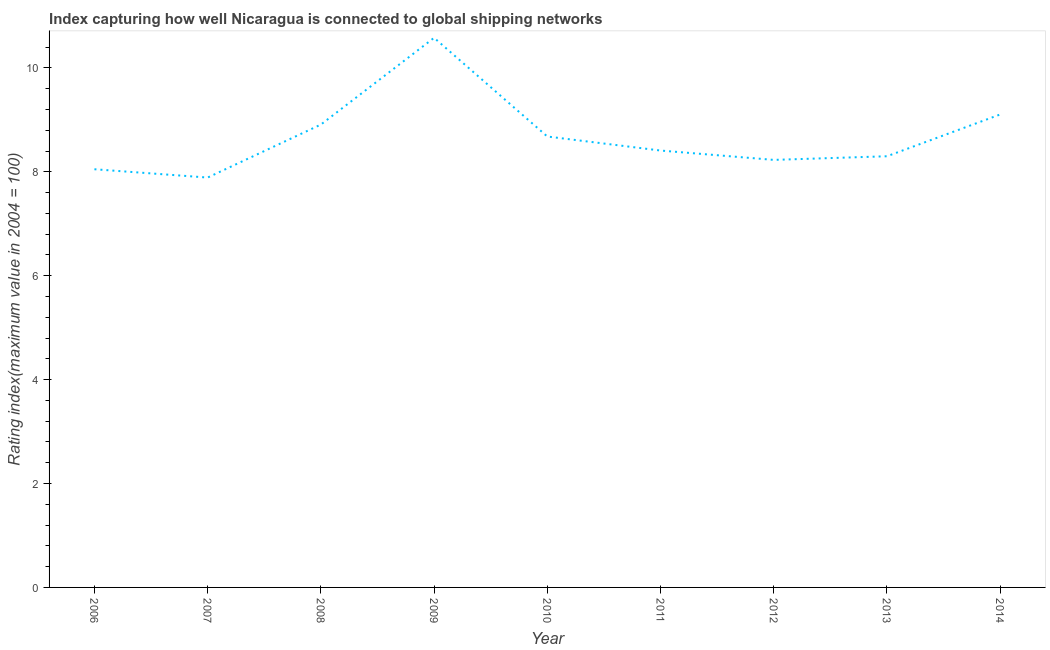What is the liner shipping connectivity index in 2009?
Give a very brief answer. 10.58. Across all years, what is the maximum liner shipping connectivity index?
Offer a very short reply. 10.58. Across all years, what is the minimum liner shipping connectivity index?
Keep it short and to the point. 7.89. What is the sum of the liner shipping connectivity index?
Ensure brevity in your answer.  78.15. What is the difference between the liner shipping connectivity index in 2012 and 2013?
Your answer should be very brief. -0.07. What is the average liner shipping connectivity index per year?
Your response must be concise. 8.68. What is the median liner shipping connectivity index?
Ensure brevity in your answer.  8.41. Do a majority of the years between 2010 and 2006 (inclusive) have liner shipping connectivity index greater than 5.6 ?
Give a very brief answer. Yes. What is the ratio of the liner shipping connectivity index in 2006 to that in 2014?
Offer a terse response. 0.88. Is the difference between the liner shipping connectivity index in 2008 and 2012 greater than the difference between any two years?
Make the answer very short. No. What is the difference between the highest and the second highest liner shipping connectivity index?
Offer a very short reply. 1.48. What is the difference between the highest and the lowest liner shipping connectivity index?
Give a very brief answer. 2.69. Does the liner shipping connectivity index monotonically increase over the years?
Your answer should be very brief. No. How many lines are there?
Your answer should be compact. 1. How many years are there in the graph?
Your response must be concise. 9. Are the values on the major ticks of Y-axis written in scientific E-notation?
Make the answer very short. No. Does the graph contain grids?
Make the answer very short. No. What is the title of the graph?
Your response must be concise. Index capturing how well Nicaragua is connected to global shipping networks. What is the label or title of the X-axis?
Keep it short and to the point. Year. What is the label or title of the Y-axis?
Provide a short and direct response. Rating index(maximum value in 2004 = 100). What is the Rating index(maximum value in 2004 = 100) of 2006?
Provide a short and direct response. 8.05. What is the Rating index(maximum value in 2004 = 100) of 2007?
Give a very brief answer. 7.89. What is the Rating index(maximum value in 2004 = 100) of 2008?
Give a very brief answer. 8.91. What is the Rating index(maximum value in 2004 = 100) in 2009?
Your response must be concise. 10.58. What is the Rating index(maximum value in 2004 = 100) of 2010?
Offer a very short reply. 8.68. What is the Rating index(maximum value in 2004 = 100) of 2011?
Offer a very short reply. 8.41. What is the Rating index(maximum value in 2004 = 100) in 2012?
Provide a succinct answer. 8.23. What is the Rating index(maximum value in 2004 = 100) of 2014?
Your answer should be compact. 9.1. What is the difference between the Rating index(maximum value in 2004 = 100) in 2006 and 2007?
Your answer should be compact. 0.16. What is the difference between the Rating index(maximum value in 2004 = 100) in 2006 and 2008?
Your answer should be compact. -0.86. What is the difference between the Rating index(maximum value in 2004 = 100) in 2006 and 2009?
Provide a succinct answer. -2.53. What is the difference between the Rating index(maximum value in 2004 = 100) in 2006 and 2010?
Make the answer very short. -0.63. What is the difference between the Rating index(maximum value in 2004 = 100) in 2006 and 2011?
Make the answer very short. -0.36. What is the difference between the Rating index(maximum value in 2004 = 100) in 2006 and 2012?
Make the answer very short. -0.18. What is the difference between the Rating index(maximum value in 2004 = 100) in 2006 and 2013?
Your response must be concise. -0.25. What is the difference between the Rating index(maximum value in 2004 = 100) in 2006 and 2014?
Your response must be concise. -1.05. What is the difference between the Rating index(maximum value in 2004 = 100) in 2007 and 2008?
Give a very brief answer. -1.02. What is the difference between the Rating index(maximum value in 2004 = 100) in 2007 and 2009?
Ensure brevity in your answer.  -2.69. What is the difference between the Rating index(maximum value in 2004 = 100) in 2007 and 2010?
Keep it short and to the point. -0.79. What is the difference between the Rating index(maximum value in 2004 = 100) in 2007 and 2011?
Offer a terse response. -0.52. What is the difference between the Rating index(maximum value in 2004 = 100) in 2007 and 2012?
Offer a terse response. -0.34. What is the difference between the Rating index(maximum value in 2004 = 100) in 2007 and 2013?
Ensure brevity in your answer.  -0.41. What is the difference between the Rating index(maximum value in 2004 = 100) in 2007 and 2014?
Ensure brevity in your answer.  -1.21. What is the difference between the Rating index(maximum value in 2004 = 100) in 2008 and 2009?
Offer a very short reply. -1.67. What is the difference between the Rating index(maximum value in 2004 = 100) in 2008 and 2010?
Provide a succinct answer. 0.23. What is the difference between the Rating index(maximum value in 2004 = 100) in 2008 and 2011?
Provide a succinct answer. 0.5. What is the difference between the Rating index(maximum value in 2004 = 100) in 2008 and 2012?
Provide a short and direct response. 0.68. What is the difference between the Rating index(maximum value in 2004 = 100) in 2008 and 2013?
Ensure brevity in your answer.  0.61. What is the difference between the Rating index(maximum value in 2004 = 100) in 2008 and 2014?
Your answer should be compact. -0.19. What is the difference between the Rating index(maximum value in 2004 = 100) in 2009 and 2011?
Make the answer very short. 2.17. What is the difference between the Rating index(maximum value in 2004 = 100) in 2009 and 2012?
Offer a very short reply. 2.35. What is the difference between the Rating index(maximum value in 2004 = 100) in 2009 and 2013?
Offer a very short reply. 2.28. What is the difference between the Rating index(maximum value in 2004 = 100) in 2009 and 2014?
Offer a very short reply. 1.48. What is the difference between the Rating index(maximum value in 2004 = 100) in 2010 and 2011?
Your response must be concise. 0.27. What is the difference between the Rating index(maximum value in 2004 = 100) in 2010 and 2012?
Ensure brevity in your answer.  0.45. What is the difference between the Rating index(maximum value in 2004 = 100) in 2010 and 2013?
Ensure brevity in your answer.  0.38. What is the difference between the Rating index(maximum value in 2004 = 100) in 2010 and 2014?
Ensure brevity in your answer.  -0.42. What is the difference between the Rating index(maximum value in 2004 = 100) in 2011 and 2012?
Offer a terse response. 0.18. What is the difference between the Rating index(maximum value in 2004 = 100) in 2011 and 2013?
Keep it short and to the point. 0.11. What is the difference between the Rating index(maximum value in 2004 = 100) in 2011 and 2014?
Offer a very short reply. -0.69. What is the difference between the Rating index(maximum value in 2004 = 100) in 2012 and 2013?
Provide a succinct answer. -0.07. What is the difference between the Rating index(maximum value in 2004 = 100) in 2012 and 2014?
Your response must be concise. -0.87. What is the difference between the Rating index(maximum value in 2004 = 100) in 2013 and 2014?
Provide a succinct answer. -0.8. What is the ratio of the Rating index(maximum value in 2004 = 100) in 2006 to that in 2008?
Make the answer very short. 0.9. What is the ratio of the Rating index(maximum value in 2004 = 100) in 2006 to that in 2009?
Give a very brief answer. 0.76. What is the ratio of the Rating index(maximum value in 2004 = 100) in 2006 to that in 2010?
Make the answer very short. 0.93. What is the ratio of the Rating index(maximum value in 2004 = 100) in 2006 to that in 2011?
Make the answer very short. 0.96. What is the ratio of the Rating index(maximum value in 2004 = 100) in 2006 to that in 2012?
Make the answer very short. 0.98. What is the ratio of the Rating index(maximum value in 2004 = 100) in 2006 to that in 2014?
Keep it short and to the point. 0.88. What is the ratio of the Rating index(maximum value in 2004 = 100) in 2007 to that in 2008?
Ensure brevity in your answer.  0.89. What is the ratio of the Rating index(maximum value in 2004 = 100) in 2007 to that in 2009?
Give a very brief answer. 0.75. What is the ratio of the Rating index(maximum value in 2004 = 100) in 2007 to that in 2010?
Ensure brevity in your answer.  0.91. What is the ratio of the Rating index(maximum value in 2004 = 100) in 2007 to that in 2011?
Offer a terse response. 0.94. What is the ratio of the Rating index(maximum value in 2004 = 100) in 2007 to that in 2012?
Make the answer very short. 0.96. What is the ratio of the Rating index(maximum value in 2004 = 100) in 2007 to that in 2013?
Provide a short and direct response. 0.95. What is the ratio of the Rating index(maximum value in 2004 = 100) in 2007 to that in 2014?
Make the answer very short. 0.87. What is the ratio of the Rating index(maximum value in 2004 = 100) in 2008 to that in 2009?
Your answer should be compact. 0.84. What is the ratio of the Rating index(maximum value in 2004 = 100) in 2008 to that in 2010?
Give a very brief answer. 1.03. What is the ratio of the Rating index(maximum value in 2004 = 100) in 2008 to that in 2011?
Make the answer very short. 1.06. What is the ratio of the Rating index(maximum value in 2004 = 100) in 2008 to that in 2012?
Provide a short and direct response. 1.08. What is the ratio of the Rating index(maximum value in 2004 = 100) in 2008 to that in 2013?
Keep it short and to the point. 1.07. What is the ratio of the Rating index(maximum value in 2004 = 100) in 2009 to that in 2010?
Your answer should be compact. 1.22. What is the ratio of the Rating index(maximum value in 2004 = 100) in 2009 to that in 2011?
Ensure brevity in your answer.  1.26. What is the ratio of the Rating index(maximum value in 2004 = 100) in 2009 to that in 2012?
Your answer should be very brief. 1.29. What is the ratio of the Rating index(maximum value in 2004 = 100) in 2009 to that in 2013?
Make the answer very short. 1.27. What is the ratio of the Rating index(maximum value in 2004 = 100) in 2009 to that in 2014?
Your answer should be compact. 1.16. What is the ratio of the Rating index(maximum value in 2004 = 100) in 2010 to that in 2011?
Keep it short and to the point. 1.03. What is the ratio of the Rating index(maximum value in 2004 = 100) in 2010 to that in 2012?
Provide a succinct answer. 1.05. What is the ratio of the Rating index(maximum value in 2004 = 100) in 2010 to that in 2013?
Your answer should be compact. 1.05. What is the ratio of the Rating index(maximum value in 2004 = 100) in 2010 to that in 2014?
Offer a very short reply. 0.95. What is the ratio of the Rating index(maximum value in 2004 = 100) in 2011 to that in 2012?
Give a very brief answer. 1.02. What is the ratio of the Rating index(maximum value in 2004 = 100) in 2011 to that in 2013?
Provide a short and direct response. 1.01. What is the ratio of the Rating index(maximum value in 2004 = 100) in 2011 to that in 2014?
Provide a succinct answer. 0.92. What is the ratio of the Rating index(maximum value in 2004 = 100) in 2012 to that in 2013?
Offer a terse response. 0.99. What is the ratio of the Rating index(maximum value in 2004 = 100) in 2012 to that in 2014?
Provide a short and direct response. 0.9. What is the ratio of the Rating index(maximum value in 2004 = 100) in 2013 to that in 2014?
Provide a short and direct response. 0.91. 